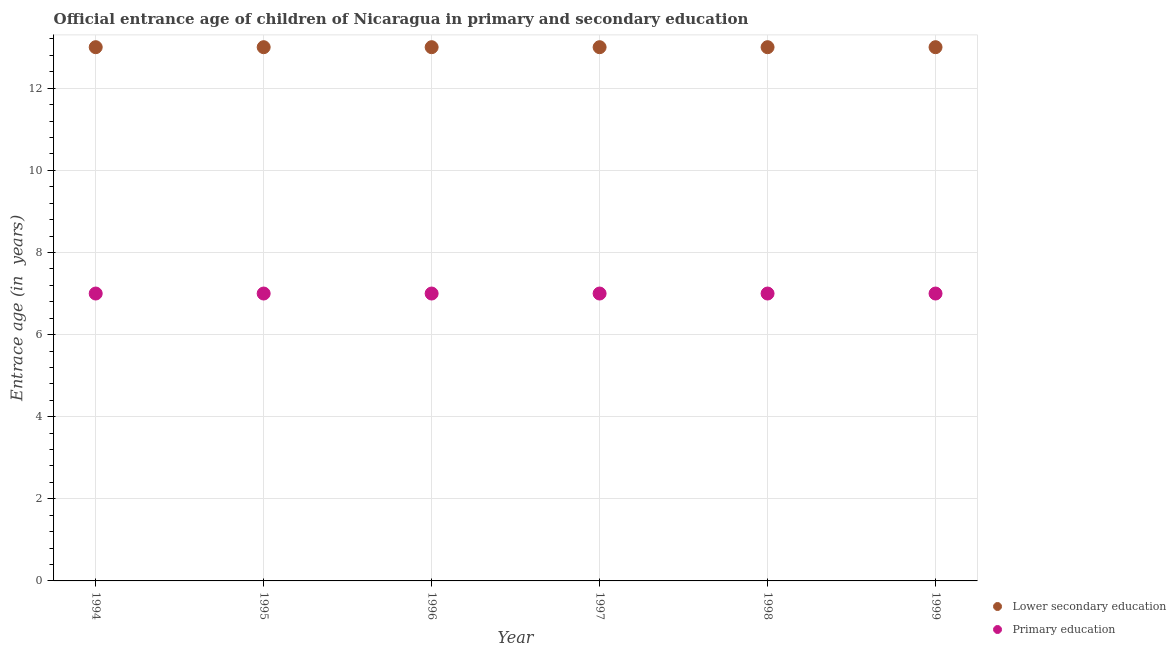How many different coloured dotlines are there?
Your answer should be compact. 2. Is the number of dotlines equal to the number of legend labels?
Keep it short and to the point. Yes. What is the entrance age of chiildren in primary education in 1995?
Offer a terse response. 7. Across all years, what is the maximum entrance age of children in lower secondary education?
Offer a terse response. 13. Across all years, what is the minimum entrance age of chiildren in primary education?
Your answer should be very brief. 7. What is the total entrance age of chiildren in primary education in the graph?
Your answer should be very brief. 42. What is the difference between the entrance age of chiildren in primary education in 1997 and the entrance age of children in lower secondary education in 1995?
Your answer should be very brief. -6. Is the entrance age of children in lower secondary education in 1994 less than that in 1998?
Offer a very short reply. No. Is the difference between the entrance age of children in lower secondary education in 1995 and 1999 greater than the difference between the entrance age of chiildren in primary education in 1995 and 1999?
Your answer should be very brief. No. What is the difference between the highest and the second highest entrance age of children in lower secondary education?
Make the answer very short. 0. What is the difference between the highest and the lowest entrance age of chiildren in primary education?
Make the answer very short. 0. In how many years, is the entrance age of chiildren in primary education greater than the average entrance age of chiildren in primary education taken over all years?
Provide a short and direct response. 0. Does the entrance age of children in lower secondary education monotonically increase over the years?
Your answer should be very brief. No. Is the entrance age of children in lower secondary education strictly less than the entrance age of chiildren in primary education over the years?
Offer a terse response. No. How many dotlines are there?
Provide a succinct answer. 2. What is the difference between two consecutive major ticks on the Y-axis?
Your answer should be very brief. 2. Does the graph contain grids?
Offer a terse response. Yes. How are the legend labels stacked?
Give a very brief answer. Vertical. What is the title of the graph?
Your answer should be compact. Official entrance age of children of Nicaragua in primary and secondary education. Does "Frequency of shipment arrival" appear as one of the legend labels in the graph?
Give a very brief answer. No. What is the label or title of the Y-axis?
Your answer should be compact. Entrace age (in  years). What is the Entrace age (in  years) in Lower secondary education in 1994?
Your answer should be very brief. 13. What is the Entrace age (in  years) of Primary education in 1994?
Offer a very short reply. 7. What is the Entrace age (in  years) in Lower secondary education in 1995?
Give a very brief answer. 13. What is the Entrace age (in  years) of Primary education in 1997?
Offer a terse response. 7. What is the Entrace age (in  years) of Lower secondary education in 1998?
Ensure brevity in your answer.  13. What is the Entrace age (in  years) of Primary education in 1999?
Make the answer very short. 7. Across all years, what is the maximum Entrace age (in  years) in Lower secondary education?
Give a very brief answer. 13. Across all years, what is the minimum Entrace age (in  years) in Lower secondary education?
Your response must be concise. 13. Across all years, what is the minimum Entrace age (in  years) in Primary education?
Offer a terse response. 7. What is the total Entrace age (in  years) in Primary education in the graph?
Your answer should be compact. 42. What is the difference between the Entrace age (in  years) in Primary education in 1994 and that in 1995?
Offer a very short reply. 0. What is the difference between the Entrace age (in  years) in Primary education in 1994 and that in 1996?
Your answer should be very brief. 0. What is the difference between the Entrace age (in  years) of Primary education in 1994 and that in 1997?
Ensure brevity in your answer.  0. What is the difference between the Entrace age (in  years) in Lower secondary education in 1994 and that in 1998?
Keep it short and to the point. 0. What is the difference between the Entrace age (in  years) of Primary education in 1994 and that in 1998?
Provide a succinct answer. 0. What is the difference between the Entrace age (in  years) of Primary education in 1994 and that in 1999?
Offer a terse response. 0. What is the difference between the Entrace age (in  years) in Lower secondary education in 1995 and that in 1996?
Provide a succinct answer. 0. What is the difference between the Entrace age (in  years) in Primary education in 1995 and that in 1996?
Give a very brief answer. 0. What is the difference between the Entrace age (in  years) in Primary education in 1995 and that in 1997?
Give a very brief answer. 0. What is the difference between the Entrace age (in  years) of Primary education in 1995 and that in 1998?
Your answer should be very brief. 0. What is the difference between the Entrace age (in  years) in Lower secondary education in 1995 and that in 1999?
Provide a succinct answer. 0. What is the difference between the Entrace age (in  years) in Primary education in 1996 and that in 1999?
Keep it short and to the point. 0. What is the difference between the Entrace age (in  years) in Lower secondary education in 1997 and that in 1999?
Offer a terse response. 0. What is the difference between the Entrace age (in  years) in Primary education in 1997 and that in 1999?
Make the answer very short. 0. What is the difference between the Entrace age (in  years) in Lower secondary education in 1998 and that in 1999?
Make the answer very short. 0. What is the difference between the Entrace age (in  years) in Primary education in 1998 and that in 1999?
Your answer should be very brief. 0. What is the difference between the Entrace age (in  years) in Lower secondary education in 1994 and the Entrace age (in  years) in Primary education in 1996?
Make the answer very short. 6. What is the difference between the Entrace age (in  years) of Lower secondary education in 1994 and the Entrace age (in  years) of Primary education in 1997?
Make the answer very short. 6. What is the difference between the Entrace age (in  years) in Lower secondary education in 1994 and the Entrace age (in  years) in Primary education in 1999?
Your answer should be compact. 6. What is the difference between the Entrace age (in  years) of Lower secondary education in 1995 and the Entrace age (in  years) of Primary education in 1996?
Provide a succinct answer. 6. What is the difference between the Entrace age (in  years) in Lower secondary education in 1995 and the Entrace age (in  years) in Primary education in 1997?
Offer a terse response. 6. What is the difference between the Entrace age (in  years) in Lower secondary education in 1995 and the Entrace age (in  years) in Primary education in 1998?
Offer a terse response. 6. What is the difference between the Entrace age (in  years) of Lower secondary education in 1996 and the Entrace age (in  years) of Primary education in 1997?
Offer a terse response. 6. What is the difference between the Entrace age (in  years) of Lower secondary education in 1996 and the Entrace age (in  years) of Primary education in 1998?
Ensure brevity in your answer.  6. What is the difference between the Entrace age (in  years) of Lower secondary education in 1996 and the Entrace age (in  years) of Primary education in 1999?
Your answer should be compact. 6. What is the difference between the Entrace age (in  years) in Lower secondary education in 1997 and the Entrace age (in  years) in Primary education in 1999?
Give a very brief answer. 6. What is the difference between the Entrace age (in  years) of Lower secondary education in 1998 and the Entrace age (in  years) of Primary education in 1999?
Keep it short and to the point. 6. What is the average Entrace age (in  years) of Lower secondary education per year?
Keep it short and to the point. 13. What is the average Entrace age (in  years) of Primary education per year?
Give a very brief answer. 7. In the year 1994, what is the difference between the Entrace age (in  years) of Lower secondary education and Entrace age (in  years) of Primary education?
Make the answer very short. 6. In the year 1995, what is the difference between the Entrace age (in  years) in Lower secondary education and Entrace age (in  years) in Primary education?
Give a very brief answer. 6. In the year 1996, what is the difference between the Entrace age (in  years) in Lower secondary education and Entrace age (in  years) in Primary education?
Ensure brevity in your answer.  6. In the year 1997, what is the difference between the Entrace age (in  years) in Lower secondary education and Entrace age (in  years) in Primary education?
Provide a short and direct response. 6. In the year 1998, what is the difference between the Entrace age (in  years) in Lower secondary education and Entrace age (in  years) in Primary education?
Make the answer very short. 6. In the year 1999, what is the difference between the Entrace age (in  years) of Lower secondary education and Entrace age (in  years) of Primary education?
Ensure brevity in your answer.  6. What is the ratio of the Entrace age (in  years) of Lower secondary education in 1994 to that in 1995?
Provide a short and direct response. 1. What is the ratio of the Entrace age (in  years) of Lower secondary education in 1994 to that in 1996?
Provide a short and direct response. 1. What is the ratio of the Entrace age (in  years) of Lower secondary education in 1994 to that in 1997?
Offer a very short reply. 1. What is the ratio of the Entrace age (in  years) of Lower secondary education in 1994 to that in 1999?
Provide a succinct answer. 1. What is the ratio of the Entrace age (in  years) of Primary education in 1994 to that in 1999?
Provide a succinct answer. 1. What is the ratio of the Entrace age (in  years) in Lower secondary education in 1995 to that in 1998?
Provide a short and direct response. 1. What is the ratio of the Entrace age (in  years) of Primary education in 1995 to that in 1998?
Your answer should be compact. 1. What is the ratio of the Entrace age (in  years) in Primary education in 1996 to that in 1997?
Your answer should be compact. 1. What is the ratio of the Entrace age (in  years) of Primary education in 1996 to that in 1998?
Keep it short and to the point. 1. What is the ratio of the Entrace age (in  years) in Lower secondary education in 1997 to that in 1999?
Your answer should be very brief. 1. What is the ratio of the Entrace age (in  years) in Primary education in 1997 to that in 1999?
Ensure brevity in your answer.  1. What is the ratio of the Entrace age (in  years) of Lower secondary education in 1998 to that in 1999?
Your answer should be very brief. 1. What is the ratio of the Entrace age (in  years) in Primary education in 1998 to that in 1999?
Your answer should be compact. 1. What is the difference between the highest and the second highest Entrace age (in  years) of Lower secondary education?
Keep it short and to the point. 0. What is the difference between the highest and the lowest Entrace age (in  years) of Lower secondary education?
Keep it short and to the point. 0. What is the difference between the highest and the lowest Entrace age (in  years) in Primary education?
Your answer should be compact. 0. 